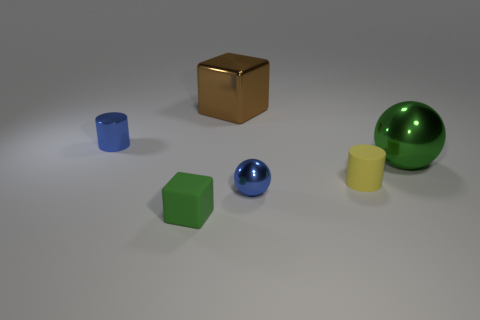Does the metal cylinder have the same color as the rubber object behind the matte block?
Your answer should be very brief. No. Is the number of green blocks greater than the number of tiny green matte balls?
Provide a short and direct response. Yes. Is there anything else of the same color as the tiny shiny cylinder?
Your answer should be compact. Yes. How many other things are the same size as the green matte thing?
Provide a succinct answer. 3. What material is the small cylinder that is in front of the metallic ball that is right of the small cylinder right of the small blue metal ball made of?
Ensure brevity in your answer.  Rubber. Are the tiny cube and the small blue thing that is in front of the small yellow thing made of the same material?
Make the answer very short. No. Is the number of big brown cubes right of the blue metallic cylinder less than the number of cylinders that are to the left of the matte cylinder?
Offer a terse response. No. What number of brown cubes have the same material as the yellow object?
Make the answer very short. 0. Is there a object that is in front of the cylinder on the right side of the small blue object on the left side of the big brown block?
Your answer should be very brief. Yes. What number of balls are either tiny green things or large objects?
Ensure brevity in your answer.  1. 